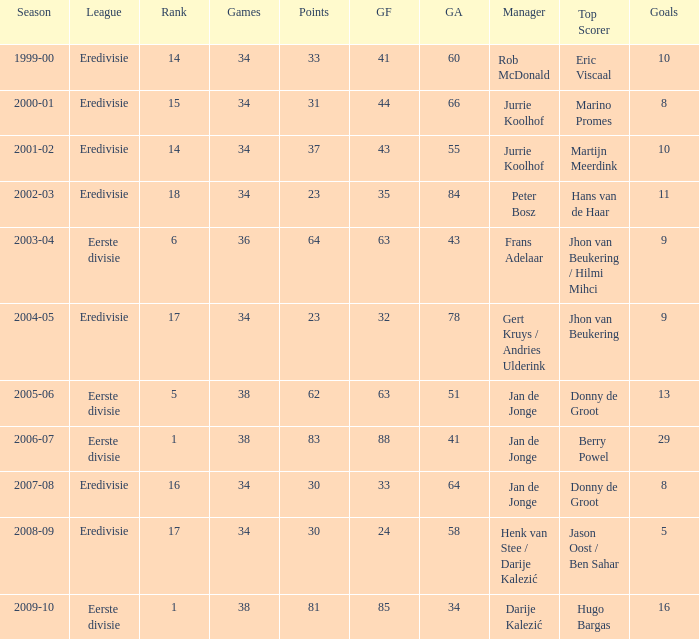What position does manager rob mcdonald hold in the ranking? 1.0. 